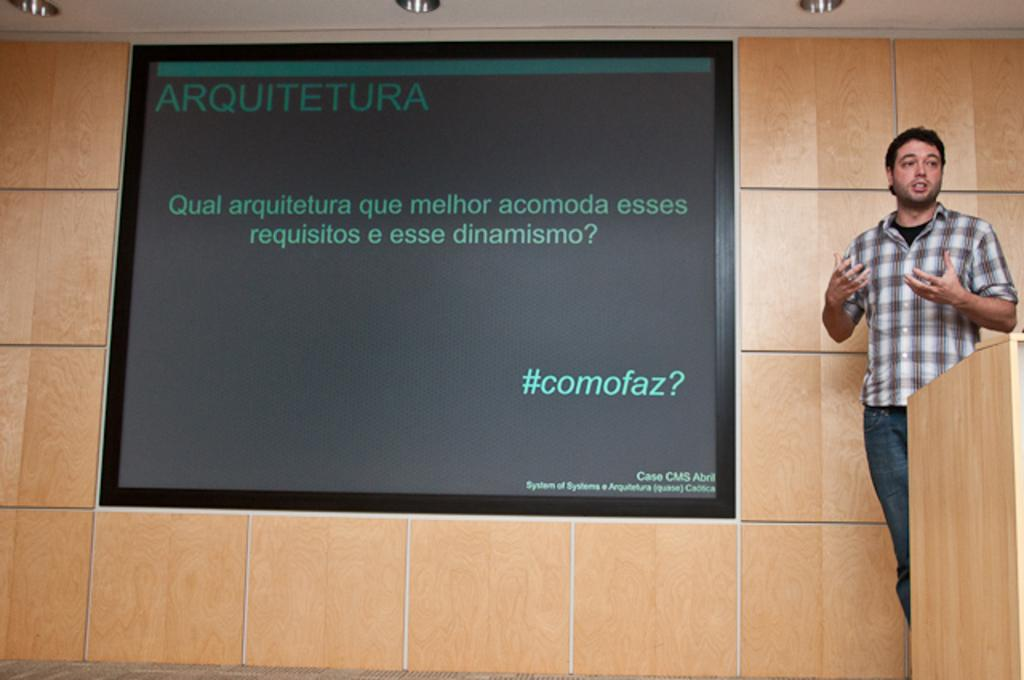Who is present in the image? There is a man in the image. What object can be seen in front of the man? There is a podium in the image. What is visible behind the man? There is a screen and a wall in the background of the image. How many deer are visible on the screen in the image? There are no deer visible on the screen in the image. What type of heart is being discussed by the man at the podium? The image does not provide any information about a heart or a discussion related to a heart. 